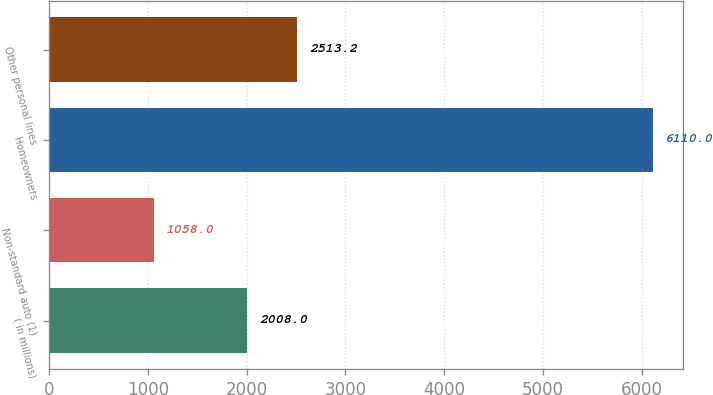Convert chart. <chart><loc_0><loc_0><loc_500><loc_500><bar_chart><fcel>( in millions)<fcel>Non-standard auto (1)<fcel>Homeowners<fcel>Other personal lines<nl><fcel>2008<fcel>1058<fcel>6110<fcel>2513.2<nl></chart> 